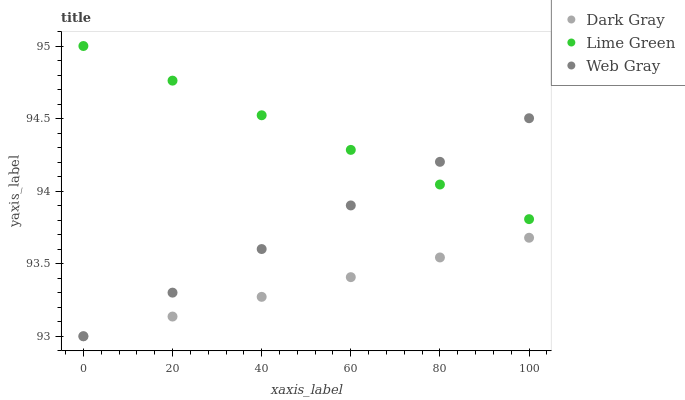Does Dark Gray have the minimum area under the curve?
Answer yes or no. Yes. Does Lime Green have the maximum area under the curve?
Answer yes or no. Yes. Does Web Gray have the minimum area under the curve?
Answer yes or no. No. Does Web Gray have the maximum area under the curve?
Answer yes or no. No. Is Lime Green the smoothest?
Answer yes or no. Yes. Is Web Gray the roughest?
Answer yes or no. Yes. Is Web Gray the smoothest?
Answer yes or no. No. Is Lime Green the roughest?
Answer yes or no. No. Does Dark Gray have the lowest value?
Answer yes or no. Yes. Does Lime Green have the lowest value?
Answer yes or no. No. Does Lime Green have the highest value?
Answer yes or no. Yes. Does Web Gray have the highest value?
Answer yes or no. No. Is Dark Gray less than Lime Green?
Answer yes or no. Yes. Is Lime Green greater than Dark Gray?
Answer yes or no. Yes. Does Lime Green intersect Web Gray?
Answer yes or no. Yes. Is Lime Green less than Web Gray?
Answer yes or no. No. Is Lime Green greater than Web Gray?
Answer yes or no. No. Does Dark Gray intersect Lime Green?
Answer yes or no. No. 